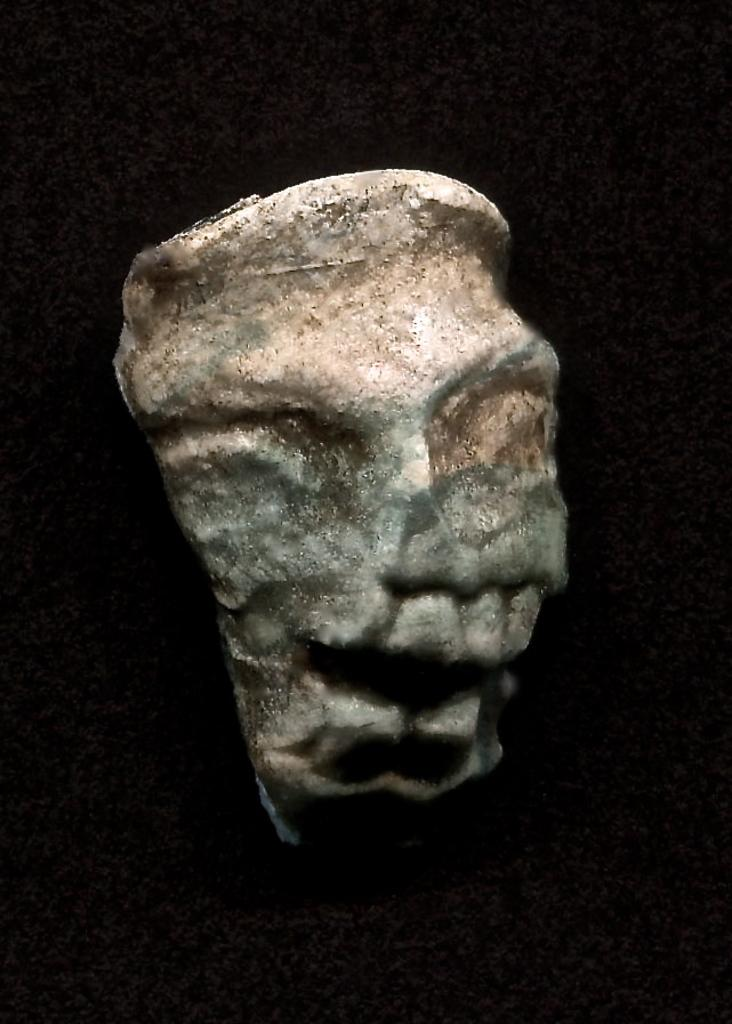What is the main subject of the image? The main subject of the image is a stone. What can be observed about the background of the image? The background of the image is dark. What type of journey is the stone embarking on in the image? The stone is not embarking on a journey in the image; it is stationary. What type of ray is interacting with the stone in the image? There is no ray present in the image; it only features a stone and a dark background. 